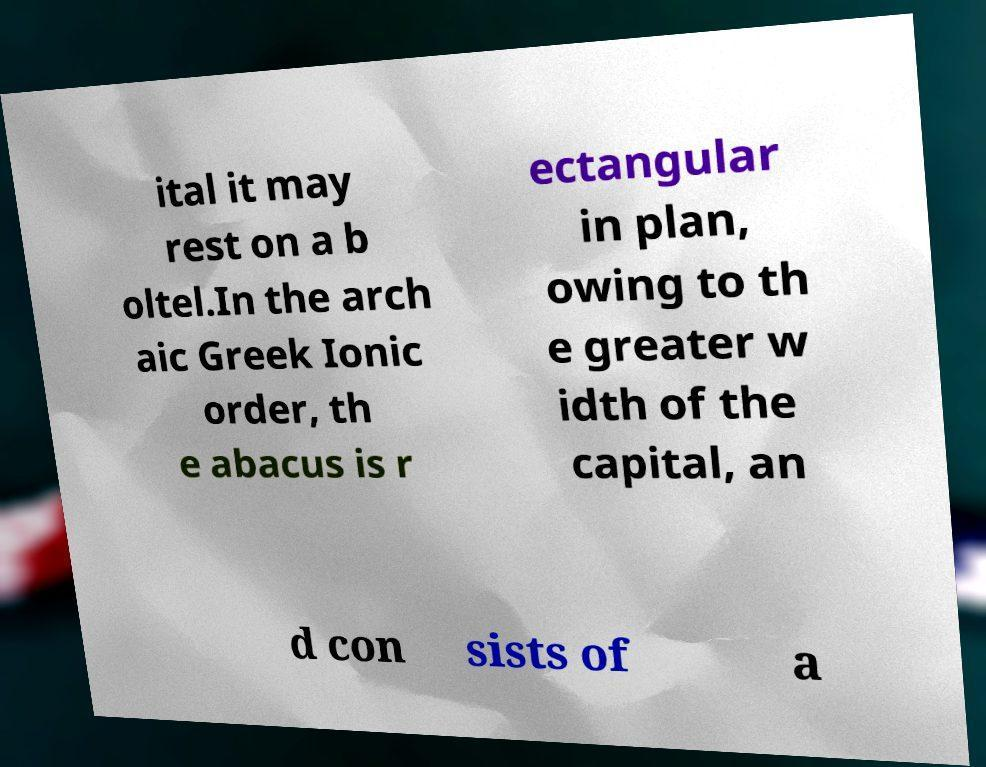For documentation purposes, I need the text within this image transcribed. Could you provide that? ital it may rest on a b oltel.In the arch aic Greek Ionic order, th e abacus is r ectangular in plan, owing to th e greater w idth of the capital, an d con sists of a 